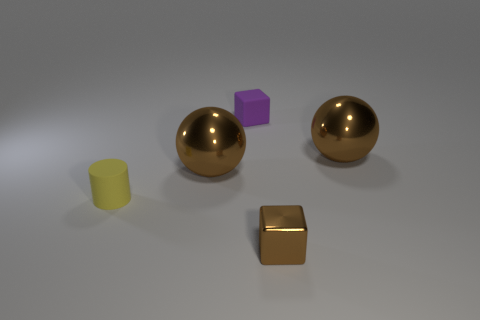How many brown spheres must be subtracted to get 1 brown spheres? 1 Subtract all blocks. How many objects are left? 3 Subtract all purple cubes. Subtract all purple cylinders. How many cubes are left? 1 Subtract all yellow cylinders. How many purple cubes are left? 1 Subtract all brown metal spheres. Subtract all small matte things. How many objects are left? 1 Add 5 tiny brown metal cubes. How many tiny brown metal cubes are left? 6 Add 2 spheres. How many spheres exist? 4 Add 4 blue cylinders. How many objects exist? 9 Subtract 0 gray cylinders. How many objects are left? 5 Subtract 1 cylinders. How many cylinders are left? 0 